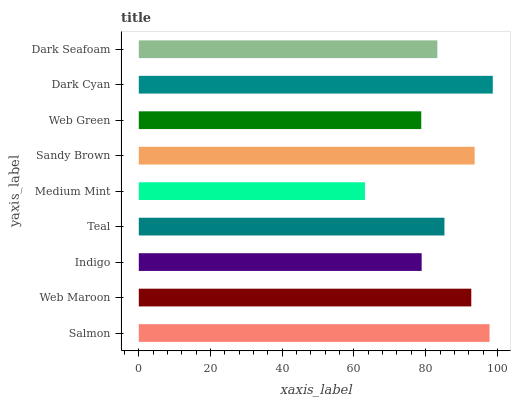Is Medium Mint the minimum?
Answer yes or no. Yes. Is Dark Cyan the maximum?
Answer yes or no. Yes. Is Web Maroon the minimum?
Answer yes or no. No. Is Web Maroon the maximum?
Answer yes or no. No. Is Salmon greater than Web Maroon?
Answer yes or no. Yes. Is Web Maroon less than Salmon?
Answer yes or no. Yes. Is Web Maroon greater than Salmon?
Answer yes or no. No. Is Salmon less than Web Maroon?
Answer yes or no. No. Is Teal the high median?
Answer yes or no. Yes. Is Teal the low median?
Answer yes or no. Yes. Is Web Maroon the high median?
Answer yes or no. No. Is Web Green the low median?
Answer yes or no. No. 